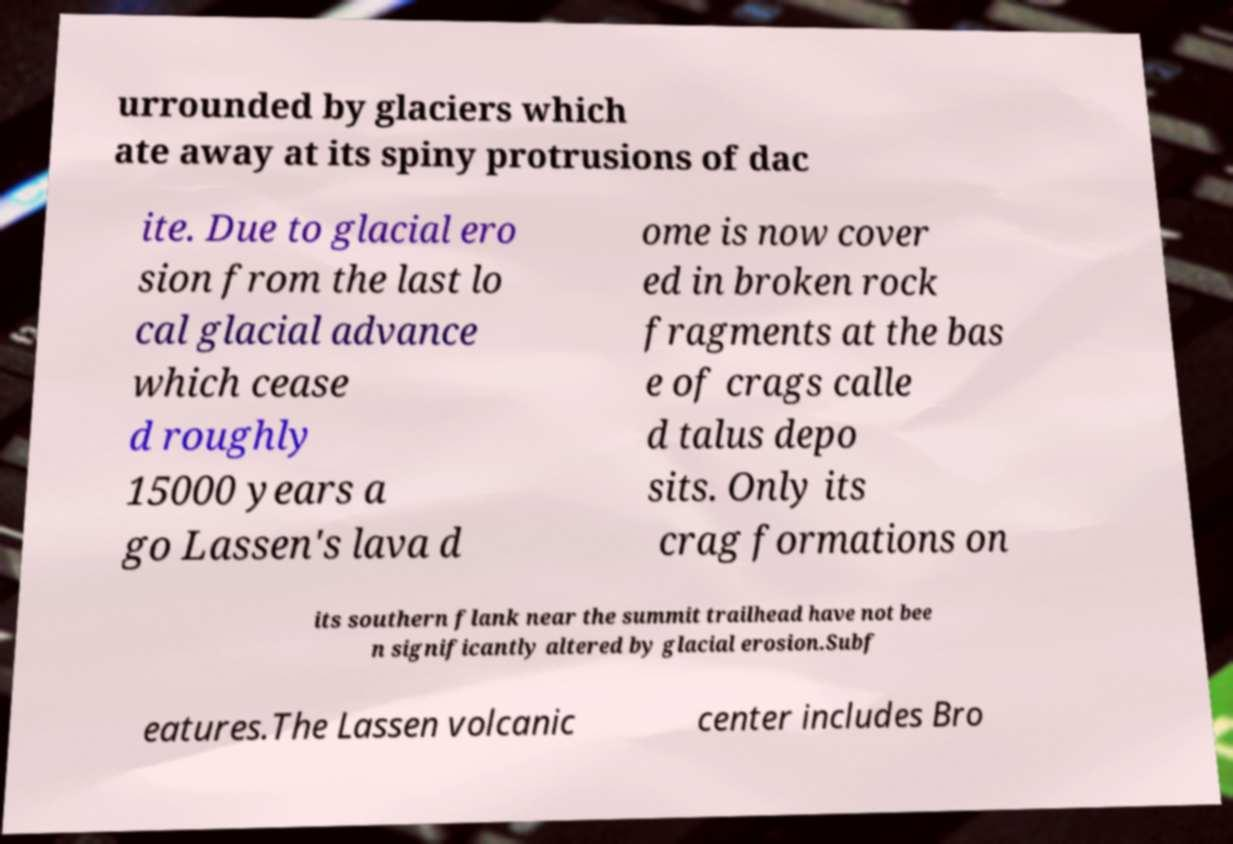For documentation purposes, I need the text within this image transcribed. Could you provide that? urrounded by glaciers which ate away at its spiny protrusions of dac ite. Due to glacial ero sion from the last lo cal glacial advance which cease d roughly 15000 years a go Lassen's lava d ome is now cover ed in broken rock fragments at the bas e of crags calle d talus depo sits. Only its crag formations on its southern flank near the summit trailhead have not bee n significantly altered by glacial erosion.Subf eatures.The Lassen volcanic center includes Bro 